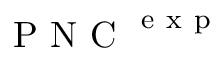<formula> <loc_0><loc_0><loc_500><loc_500>P N C ^ { e x p }</formula> 